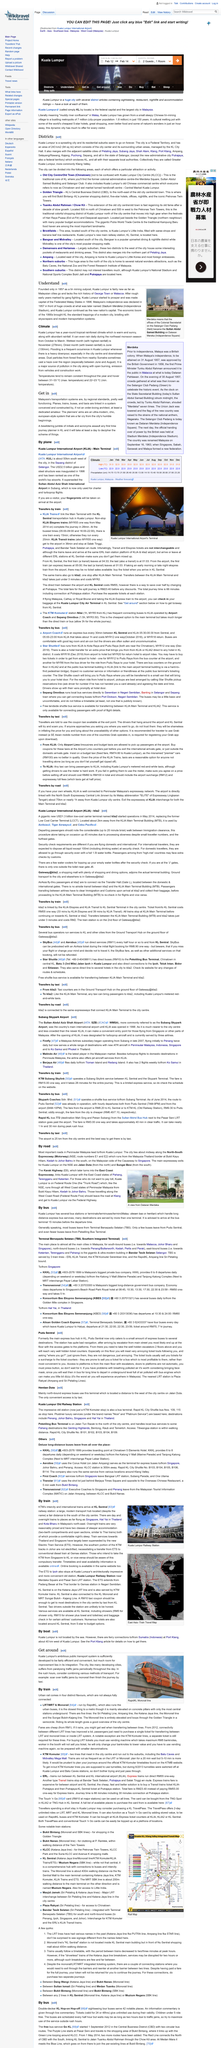Outline some significant characteristics in this image. Malaysia's transport systems are well functioning, relative to the standards of the region. Yes, Kuala Lumpur has multiple districts. Subang Jaya is one of Kuala Lumpur's adjacent satellite cities, and it is located very close to the capital city. A journey planner in Kuala Lumpur would be for the planning of journeys within Malaysia. Kuala Lumpur has an area of 243 km2 (94 sq mi). 